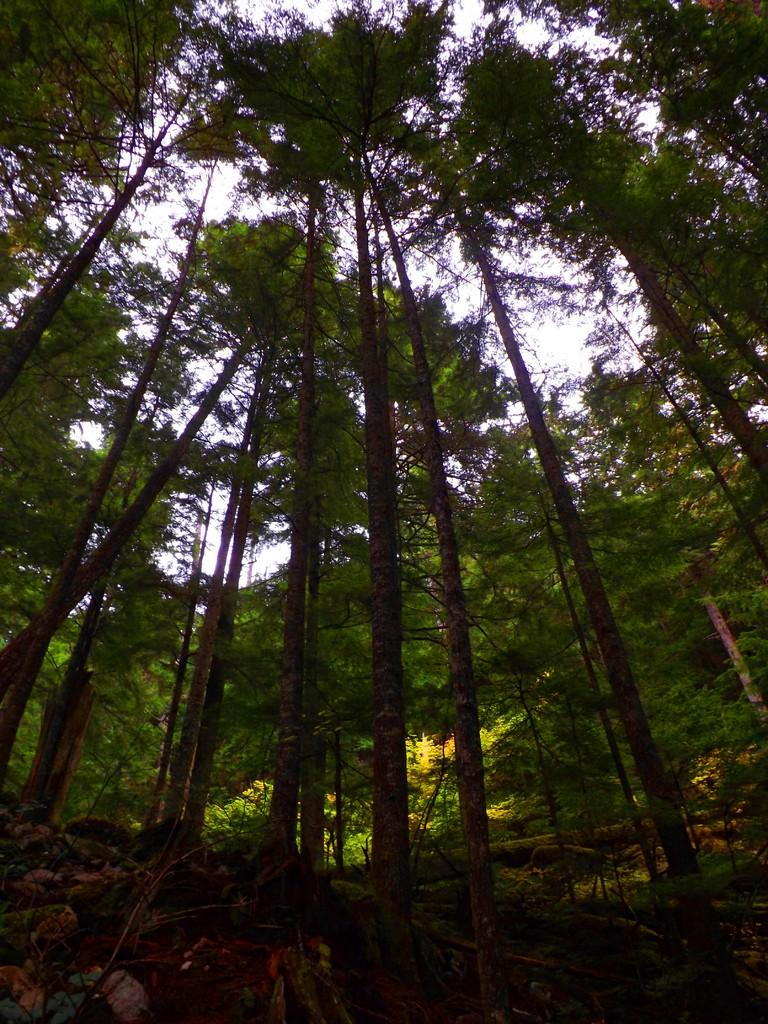What type of natural elements can be seen in the image? There are trees and plants in the image. Where are the trees and plants located in the image? The trees and plants are on the ground in the image. What is visible in the background of the image? The sky is visible in the background of the image. What type of advertisement can be seen on the trees in the image? There is no advertisement present on the trees in the image; only trees and plants are visible. What type of disease can be seen affecting the plants in the image? There is no disease affecting the plants in the image; the plants appear healthy. 